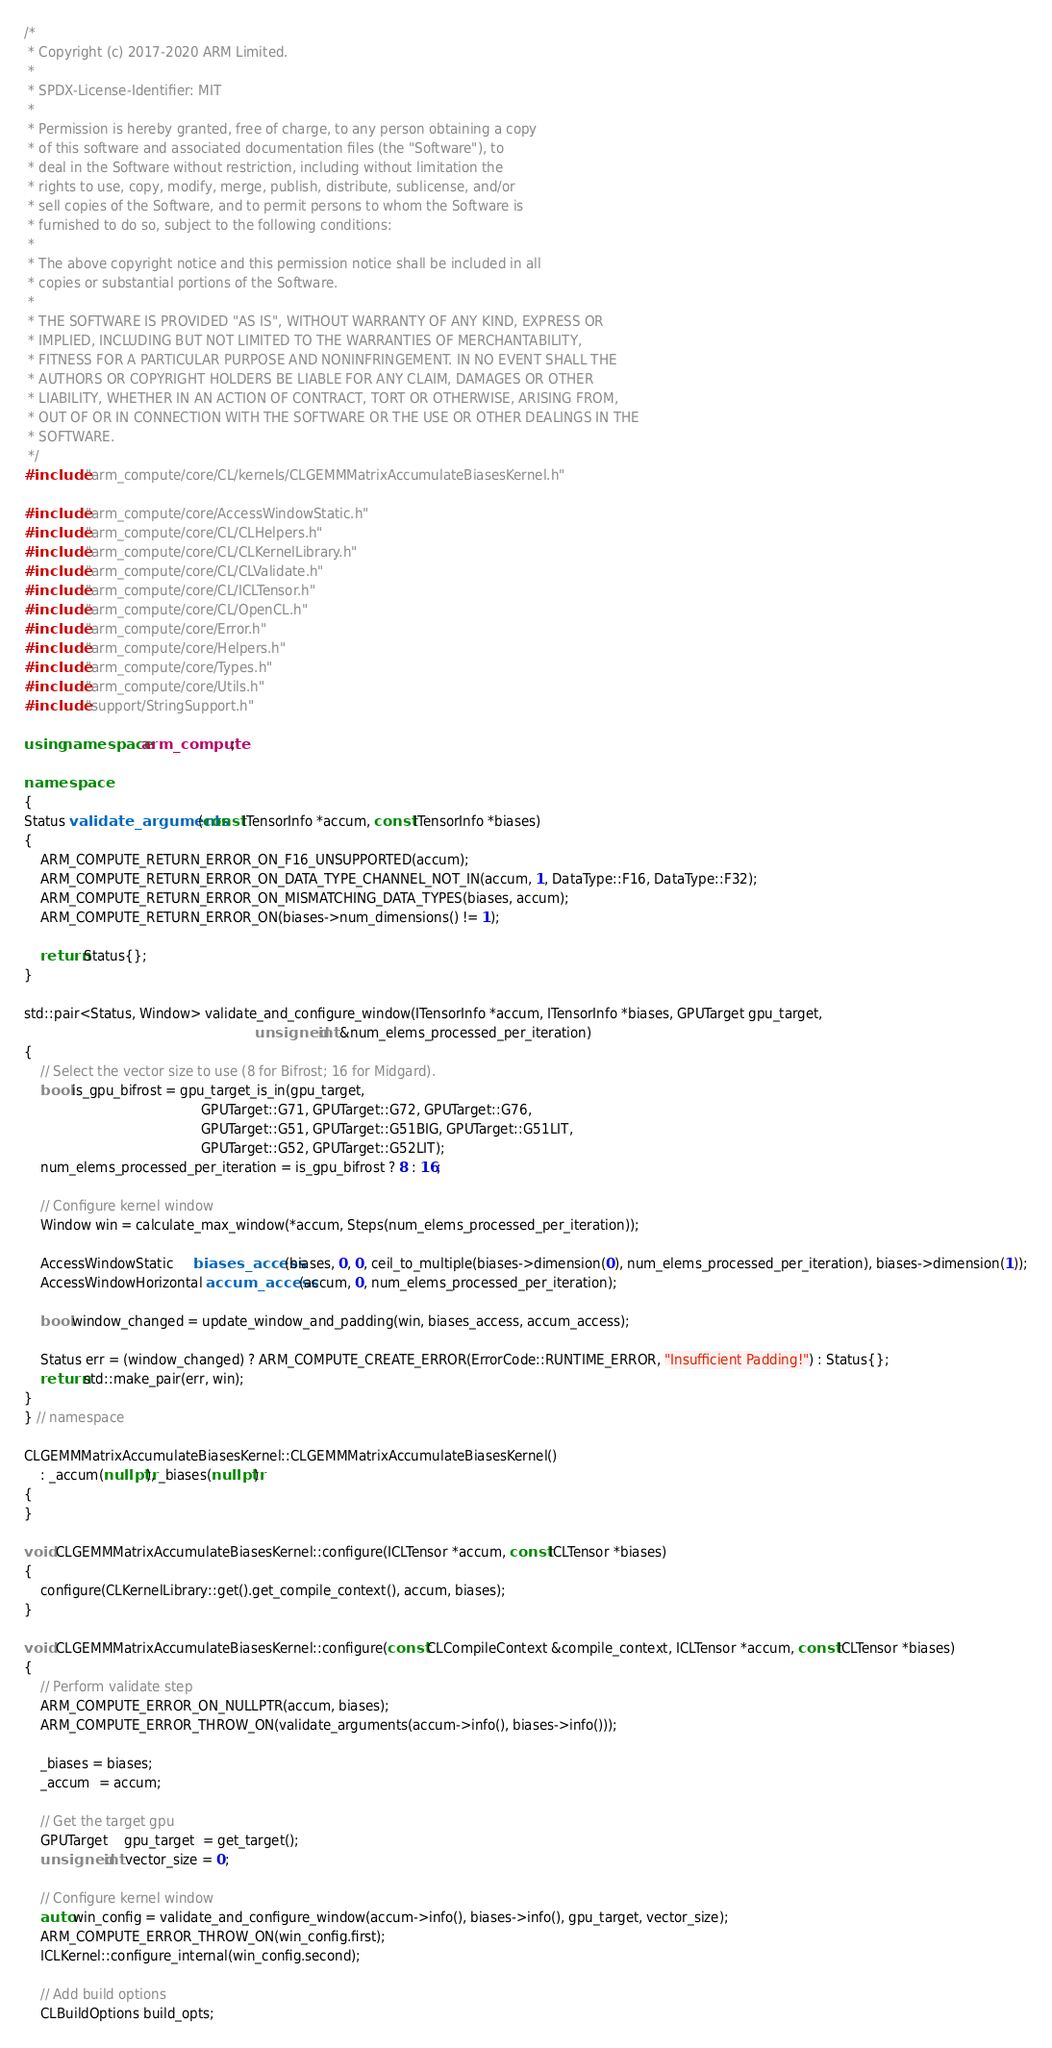<code> <loc_0><loc_0><loc_500><loc_500><_C++_>/*
 * Copyright (c) 2017-2020 ARM Limited.
 *
 * SPDX-License-Identifier: MIT
 *
 * Permission is hereby granted, free of charge, to any person obtaining a copy
 * of this software and associated documentation files (the "Software"), to
 * deal in the Software without restriction, including without limitation the
 * rights to use, copy, modify, merge, publish, distribute, sublicense, and/or
 * sell copies of the Software, and to permit persons to whom the Software is
 * furnished to do so, subject to the following conditions:
 *
 * The above copyright notice and this permission notice shall be included in all
 * copies or substantial portions of the Software.
 *
 * THE SOFTWARE IS PROVIDED "AS IS", WITHOUT WARRANTY OF ANY KIND, EXPRESS OR
 * IMPLIED, INCLUDING BUT NOT LIMITED TO THE WARRANTIES OF MERCHANTABILITY,
 * FITNESS FOR A PARTICULAR PURPOSE AND NONINFRINGEMENT. IN NO EVENT SHALL THE
 * AUTHORS OR COPYRIGHT HOLDERS BE LIABLE FOR ANY CLAIM, DAMAGES OR OTHER
 * LIABILITY, WHETHER IN AN ACTION OF CONTRACT, TORT OR OTHERWISE, ARISING FROM,
 * OUT OF OR IN CONNECTION WITH THE SOFTWARE OR THE USE OR OTHER DEALINGS IN THE
 * SOFTWARE.
 */
#include "arm_compute/core/CL/kernels/CLGEMMMatrixAccumulateBiasesKernel.h"

#include "arm_compute/core/AccessWindowStatic.h"
#include "arm_compute/core/CL/CLHelpers.h"
#include "arm_compute/core/CL/CLKernelLibrary.h"
#include "arm_compute/core/CL/CLValidate.h"
#include "arm_compute/core/CL/ICLTensor.h"
#include "arm_compute/core/CL/OpenCL.h"
#include "arm_compute/core/Error.h"
#include "arm_compute/core/Helpers.h"
#include "arm_compute/core/Types.h"
#include "arm_compute/core/Utils.h"
#include "support/StringSupport.h"

using namespace arm_compute;

namespace
{
Status validate_arguments(const ITensorInfo *accum, const ITensorInfo *biases)
{
    ARM_COMPUTE_RETURN_ERROR_ON_F16_UNSUPPORTED(accum);
    ARM_COMPUTE_RETURN_ERROR_ON_DATA_TYPE_CHANNEL_NOT_IN(accum, 1, DataType::F16, DataType::F32);
    ARM_COMPUTE_RETURN_ERROR_ON_MISMATCHING_DATA_TYPES(biases, accum);
    ARM_COMPUTE_RETURN_ERROR_ON(biases->num_dimensions() != 1);

    return Status{};
}

std::pair<Status, Window> validate_and_configure_window(ITensorInfo *accum, ITensorInfo *biases, GPUTarget gpu_target,
                                                        unsigned int &num_elems_processed_per_iteration)
{
    // Select the vector size to use (8 for Bifrost; 16 for Midgard).
    bool is_gpu_bifrost = gpu_target_is_in(gpu_target,
                                           GPUTarget::G71, GPUTarget::G72, GPUTarget::G76,
                                           GPUTarget::G51, GPUTarget::G51BIG, GPUTarget::G51LIT,
                                           GPUTarget::G52, GPUTarget::G52LIT);
    num_elems_processed_per_iteration = is_gpu_bifrost ? 8 : 16;

    // Configure kernel window
    Window win = calculate_max_window(*accum, Steps(num_elems_processed_per_iteration));

    AccessWindowStatic     biases_access(biases, 0, 0, ceil_to_multiple(biases->dimension(0), num_elems_processed_per_iteration), biases->dimension(1));
    AccessWindowHorizontal accum_access(accum, 0, num_elems_processed_per_iteration);

    bool window_changed = update_window_and_padding(win, biases_access, accum_access);

    Status err = (window_changed) ? ARM_COMPUTE_CREATE_ERROR(ErrorCode::RUNTIME_ERROR, "Insufficient Padding!") : Status{};
    return std::make_pair(err, win);
}
} // namespace

CLGEMMMatrixAccumulateBiasesKernel::CLGEMMMatrixAccumulateBiasesKernel()
    : _accum(nullptr), _biases(nullptr)
{
}

void CLGEMMMatrixAccumulateBiasesKernel::configure(ICLTensor *accum, const ICLTensor *biases)
{
    configure(CLKernelLibrary::get().get_compile_context(), accum, biases);
}

void CLGEMMMatrixAccumulateBiasesKernel::configure(const CLCompileContext &compile_context, ICLTensor *accum, const ICLTensor *biases)
{
    // Perform validate step
    ARM_COMPUTE_ERROR_ON_NULLPTR(accum, biases);
    ARM_COMPUTE_ERROR_THROW_ON(validate_arguments(accum->info(), biases->info()));

    _biases = biases;
    _accum  = accum;

    // Get the target gpu
    GPUTarget    gpu_target  = get_target();
    unsigned int vector_size = 0;

    // Configure kernel window
    auto win_config = validate_and_configure_window(accum->info(), biases->info(), gpu_target, vector_size);
    ARM_COMPUTE_ERROR_THROW_ON(win_config.first);
    ICLKernel::configure_internal(win_config.second);

    // Add build options
    CLBuildOptions build_opts;</code> 